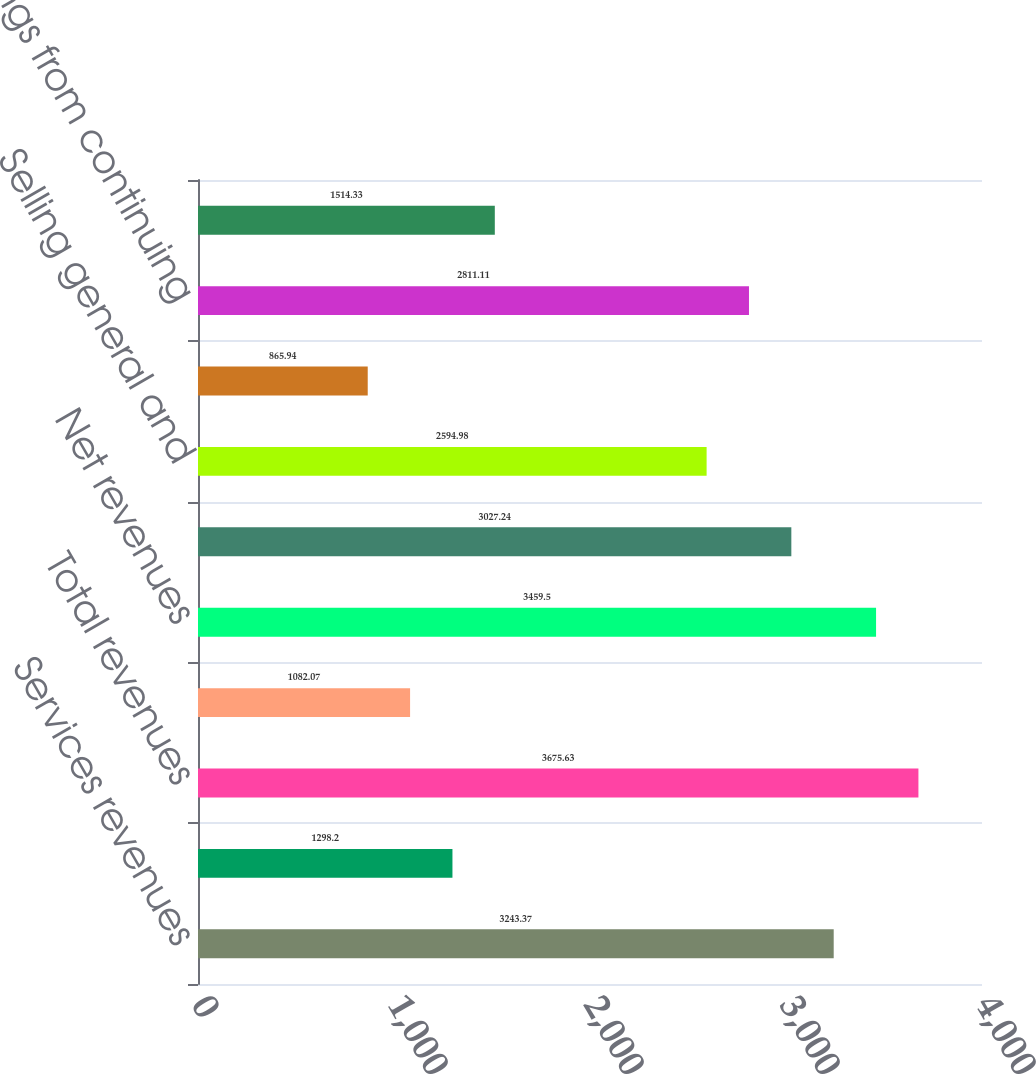Convert chart to OTSL. <chart><loc_0><loc_0><loc_500><loc_500><bar_chart><fcel>Services revenues<fcel>Other<fcel>Total revenues<fcel>Interest expense from<fcel>Net revenues<fcel>Cost of net revenues<fcel>Selling general and<fcel>Other expenses net<fcel>Earnings from continuing<fcel>Provision for income taxes<nl><fcel>3243.37<fcel>1298.2<fcel>3675.63<fcel>1082.07<fcel>3459.5<fcel>3027.24<fcel>2594.98<fcel>865.94<fcel>2811.11<fcel>1514.33<nl></chart> 